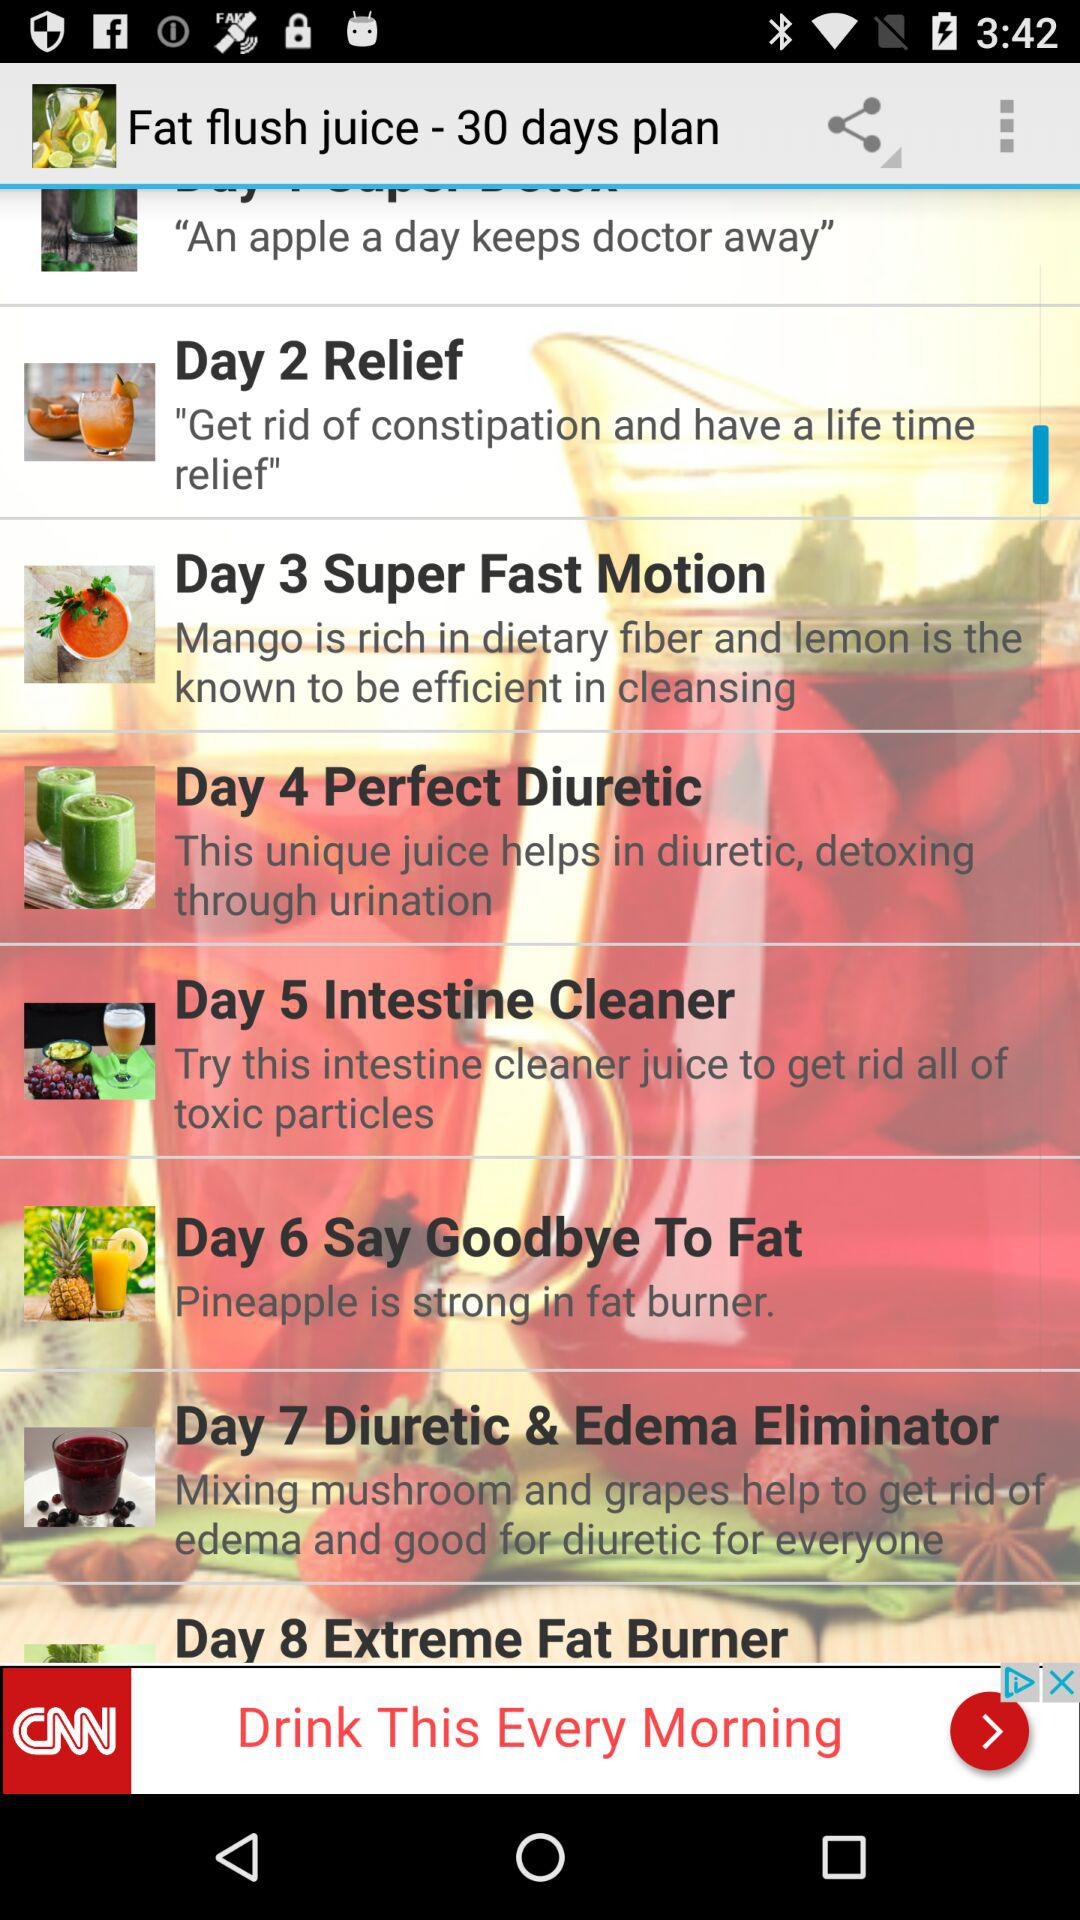How many days are there between the 'Relief' and 'Super Fast Motion' days?
Answer the question using a single word or phrase. 1 